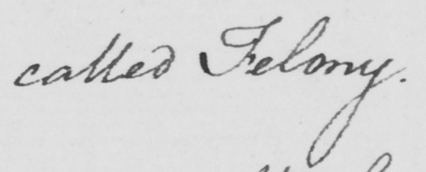What does this handwritten line say? called Felony . 